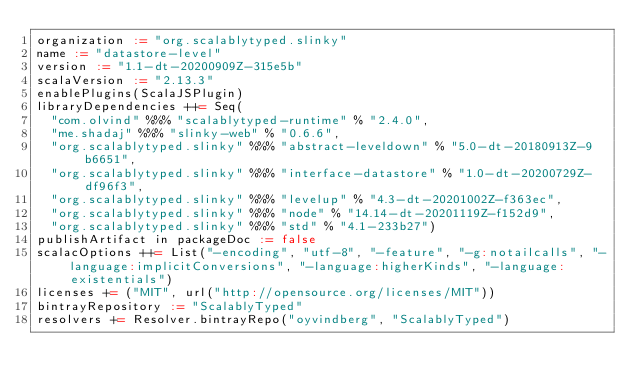<code> <loc_0><loc_0><loc_500><loc_500><_Scala_>organization := "org.scalablytyped.slinky"
name := "datastore-level"
version := "1.1-dt-20200909Z-315e5b"
scalaVersion := "2.13.3"
enablePlugins(ScalaJSPlugin)
libraryDependencies ++= Seq(
  "com.olvind" %%% "scalablytyped-runtime" % "2.4.0",
  "me.shadaj" %%% "slinky-web" % "0.6.6",
  "org.scalablytyped.slinky" %%% "abstract-leveldown" % "5.0-dt-20180913Z-9b6651",
  "org.scalablytyped.slinky" %%% "interface-datastore" % "1.0-dt-20200729Z-df96f3",
  "org.scalablytyped.slinky" %%% "levelup" % "4.3-dt-20201002Z-f363ec",
  "org.scalablytyped.slinky" %%% "node" % "14.14-dt-20201119Z-f152d9",
  "org.scalablytyped.slinky" %%% "std" % "4.1-233b27")
publishArtifact in packageDoc := false
scalacOptions ++= List("-encoding", "utf-8", "-feature", "-g:notailcalls", "-language:implicitConversions", "-language:higherKinds", "-language:existentials")
licenses += ("MIT", url("http://opensource.org/licenses/MIT"))
bintrayRepository := "ScalablyTyped"
resolvers += Resolver.bintrayRepo("oyvindberg", "ScalablyTyped")
</code> 